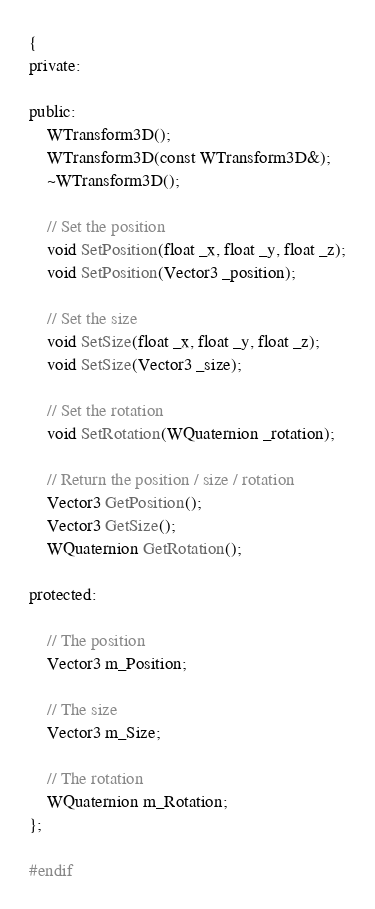Convert code to text. <code><loc_0><loc_0><loc_500><loc_500><_C_>{
private:

public:
	WTransform3D();
	WTransform3D(const WTransform3D&);
	~WTransform3D();

	// Set the position
	void SetPosition(float _x, float _y, float _z);
	void SetPosition(Vector3 _position);

	// Set the size
	void SetSize(float _x, float _y, float _z);
	void SetSize(Vector3 _size);

	// Set the rotation
	void SetRotation(WQuaternion _rotation);

	// Return the position / size / rotation
	Vector3 GetPosition();
	Vector3 GetSize();
	WQuaternion GetRotation();

protected:

	// The position
	Vector3 m_Position;

	// The size
	Vector3 m_Size;

	// The rotation
	WQuaternion m_Rotation;
};

#endif
</code> 